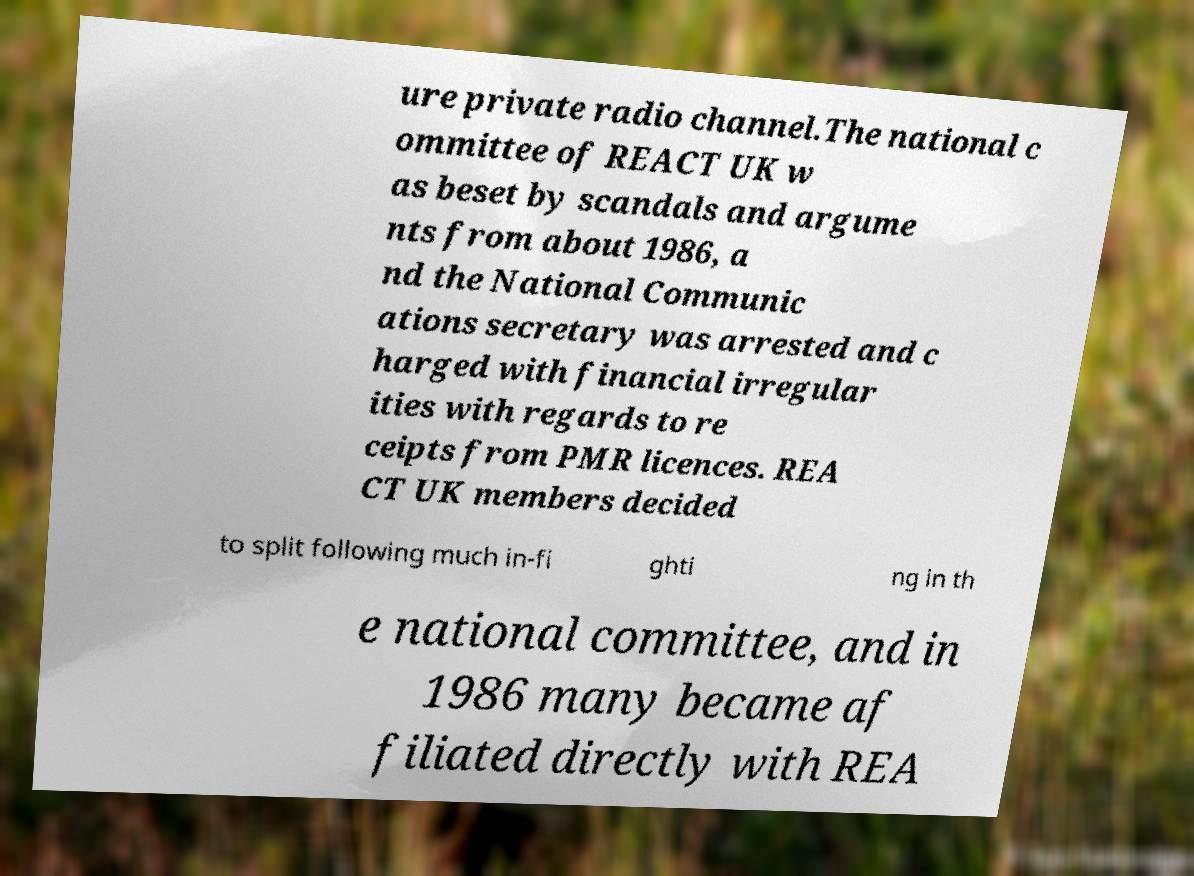Can you accurately transcribe the text from the provided image for me? ure private radio channel.The national c ommittee of REACT UK w as beset by scandals and argume nts from about 1986, a nd the National Communic ations secretary was arrested and c harged with financial irregular ities with regards to re ceipts from PMR licences. REA CT UK members decided to split following much in-fi ghti ng in th e national committee, and in 1986 many became af filiated directly with REA 